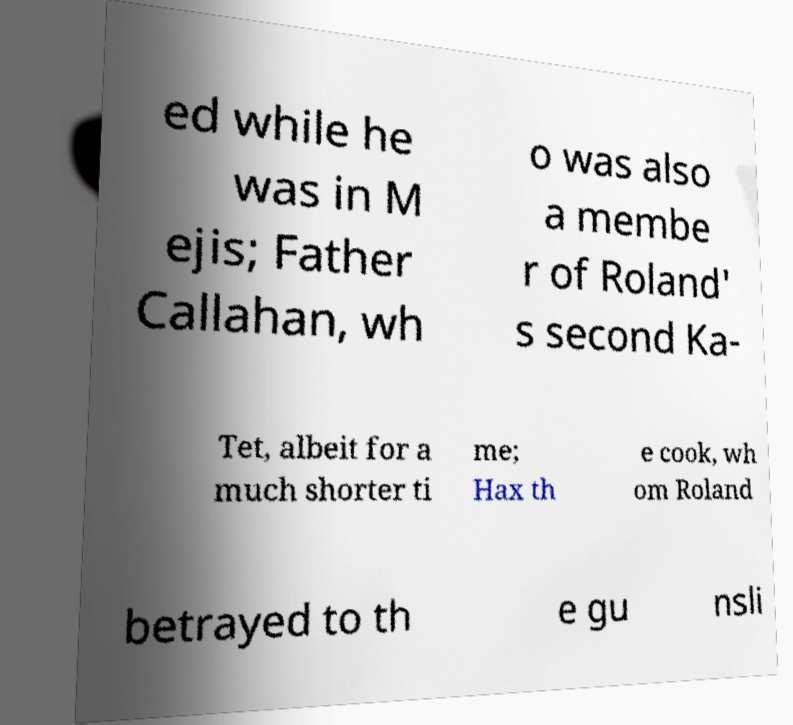Could you extract and type out the text from this image? ed while he was in M ejis; Father Callahan, wh o was also a membe r of Roland' s second Ka- Tet, albeit for a much shorter ti me; Hax th e cook, wh om Roland betrayed to th e gu nsli 